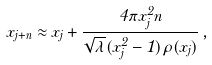<formula> <loc_0><loc_0><loc_500><loc_500>x _ { j + n } \approx x _ { j } + \frac { 4 \pi x _ { j } ^ { 2 } n } { \sqrt { \lambda } ( x _ { j } ^ { 2 } - 1 ) \rho ( x _ { j } ) } \, ,</formula> 